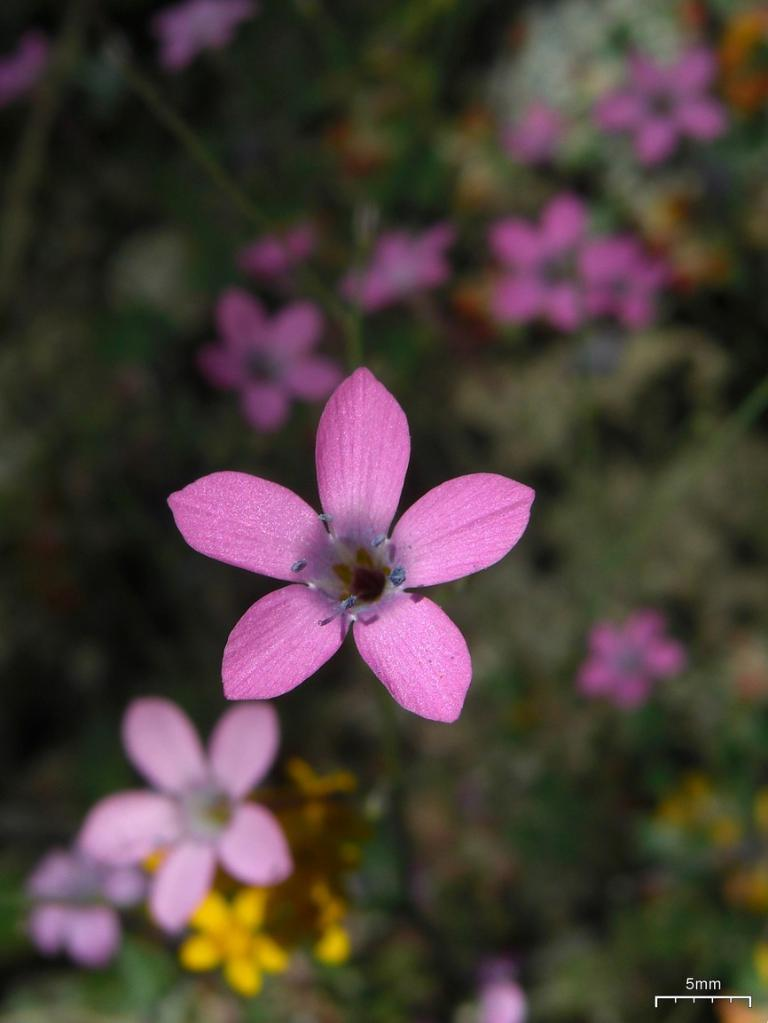What type of living organisms can be seen in the image? There are flowers in the image. Can you describe the main flower in the image? There is a flower in the center of the image, and it has pink petals. What can be found in the center of the flower? There are pollen grains in the center of the flower. How would you describe the background of the image? The background of the image is blurry. What type of committee is responsible for the expansion of the snakes in the image? There are no snakes present in the image, and therefore no committee or expansion is relevant to the image. 